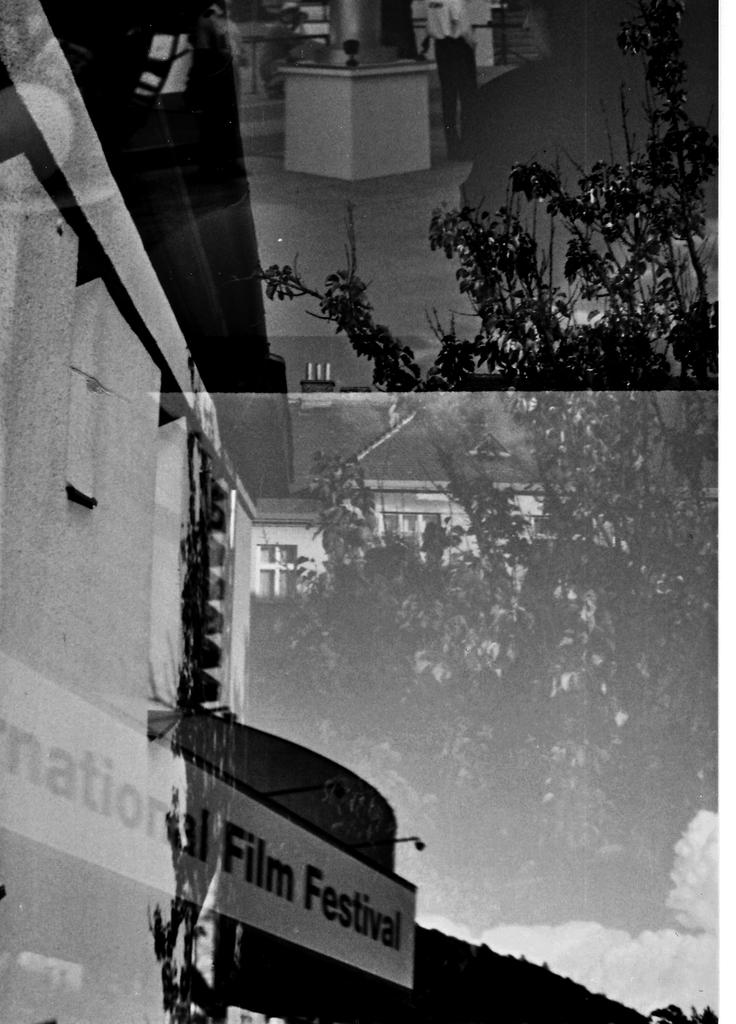What type of structures can be seen in the image? There are buildings in the image. What type of vegetation is present in the image? There is a tree in the image. Are there any words or letters visible in the image? Yes, there is text visible in the image. What is the color scheme of the image? The image is black and white in color. Where is the shelf located in the image? There is no shelf present in the image. What type of structure is the tree in the image? The tree is a natural structure, not a man-made one like a building. 